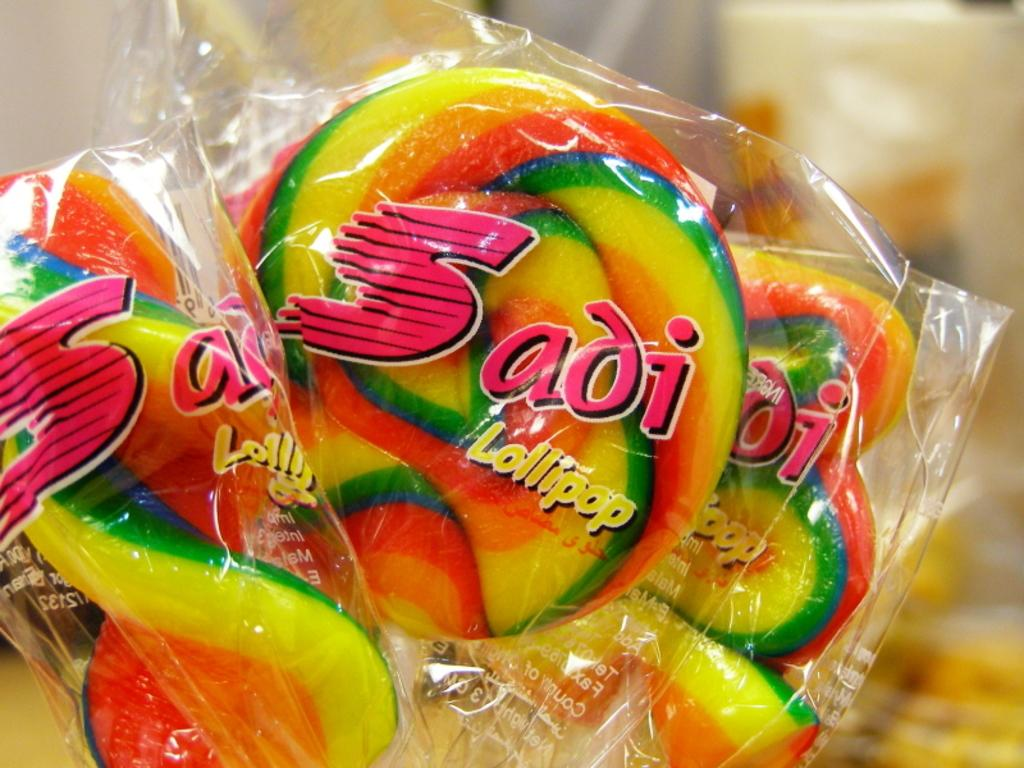What type of objects are in the foreground of the image? There are candies in the foreground of the image. How are the candies packaged? The candies are wrapped in a cover. Can you describe the background of the image? The background of the image is blurred. What is the shape of the square in the image? There is no square present in the image. What time of day is depicted in the image? The time of day cannot be determined from the image, as there is no indication of lighting or shadows. 